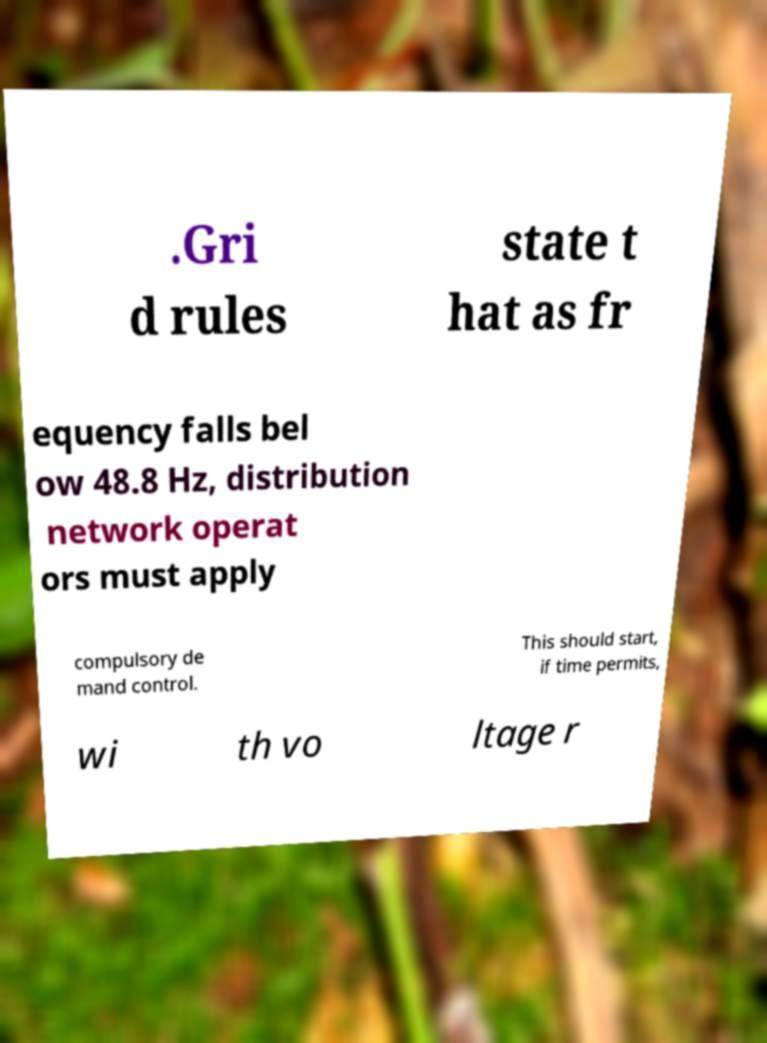Could you extract and type out the text from this image? .Gri d rules state t hat as fr equency falls bel ow 48.8 Hz, distribution network operat ors must apply compulsory de mand control. This should start, if time permits, wi th vo ltage r 